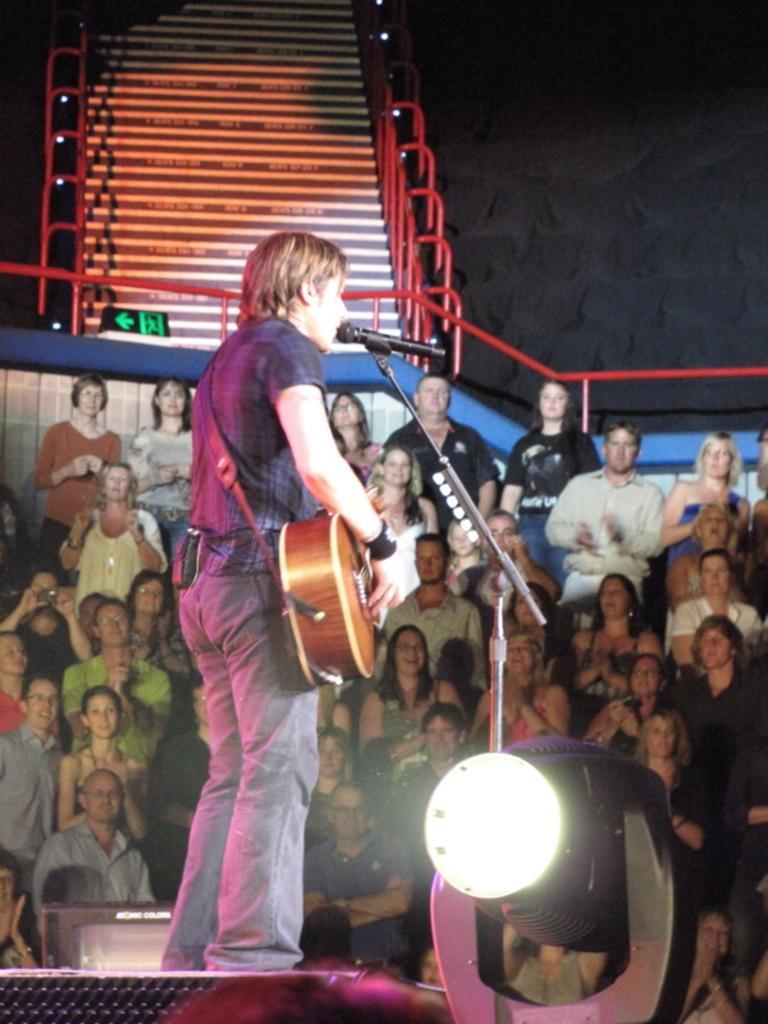Describe this image in one or two sentences. This image is clicked in a concert. In the front, there is a man playing guitar. To the bottom right, there is a light. In the background there is crowd. At the top, there is a stand. 